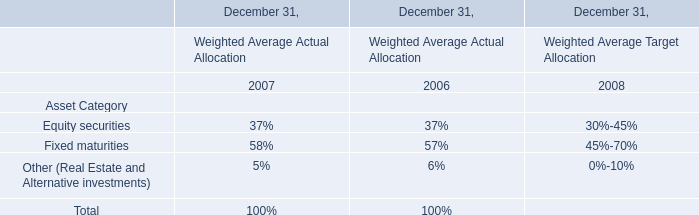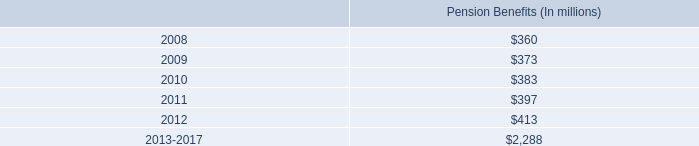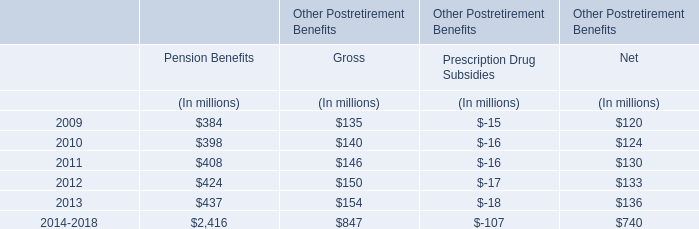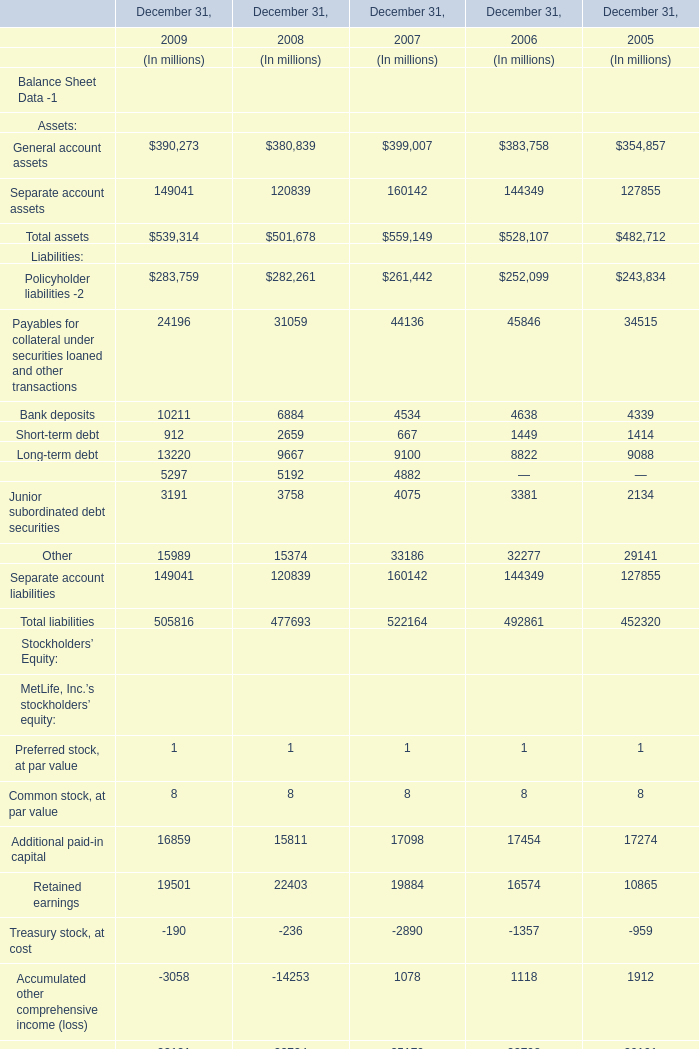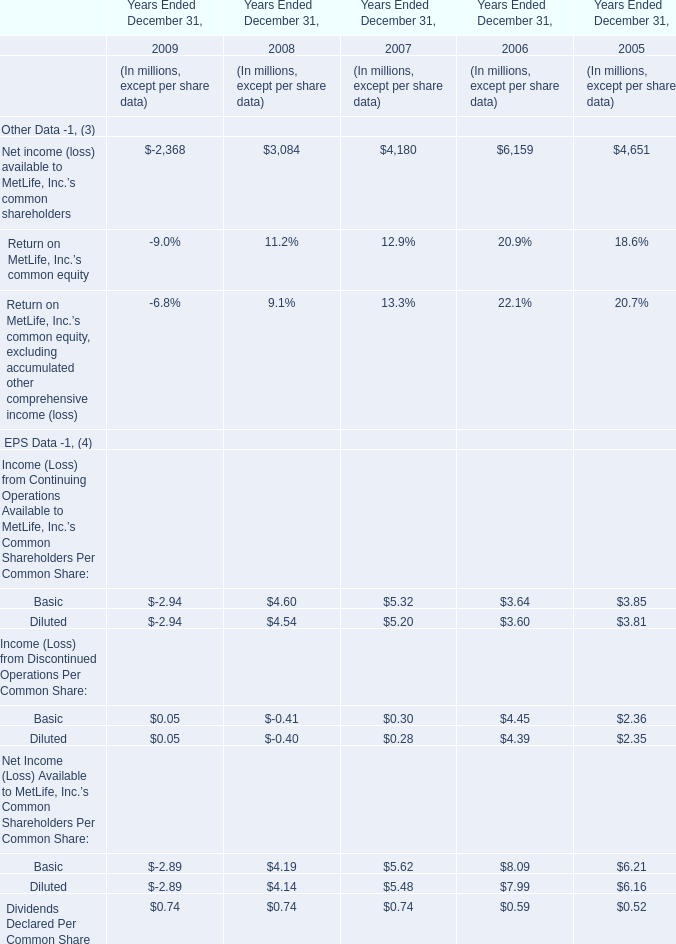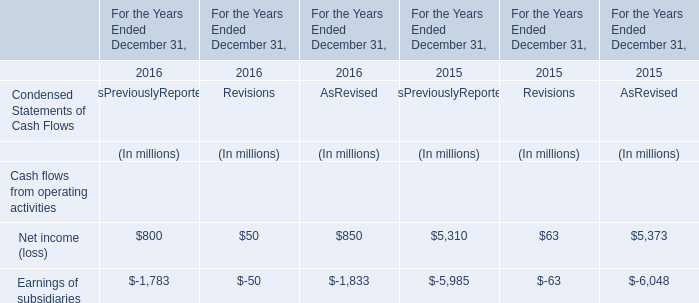What is the sum of the Junior subordinated debt securities in the years where Total liabilities is positive? (in million) 
Computations: ((((3191 + 3758) + 4075) + 3381) + 2134)
Answer: 16539.0. 